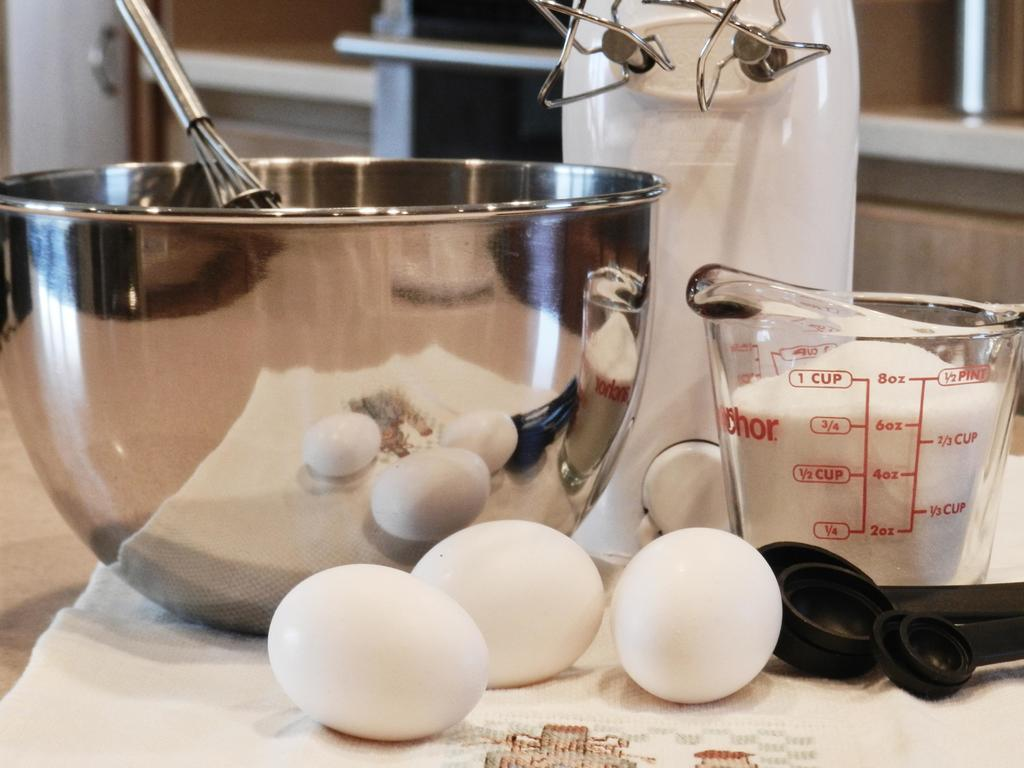<image>
Present a compact description of the photo's key features. A mixing bowl with 6oz of sugar in a glass jar sits on a table. 